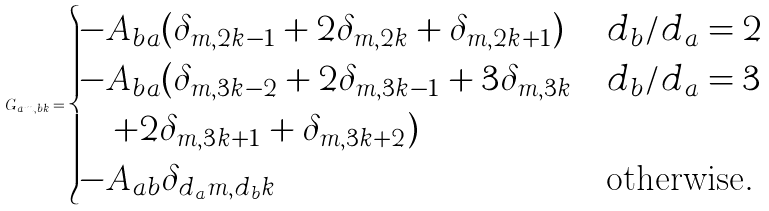<formula> <loc_0><loc_0><loc_500><loc_500>G _ { a m , b k } = \begin{cases} - A _ { b a } ( \delta _ { m , 2 k - 1 } + 2 \delta _ { m , 2 k } + \delta _ { m , 2 k + 1 } ) & d _ { b } / d _ { a } = 2 \\ - A _ { b a } ( \delta _ { m , 3 k - 2 } + 2 \delta _ { m , 3 k - 1 } + 3 \delta _ { m , 3 k } & d _ { b } / d _ { a } = 3 \\ \quad + 2 \delta _ { m , 3 k + 1 } + \delta _ { m , 3 k + 2 } ) & \\ - A _ { a b } \delta _ { d _ { a } m , d _ { b } k } & \text {otherwise} . \end{cases}</formula> 